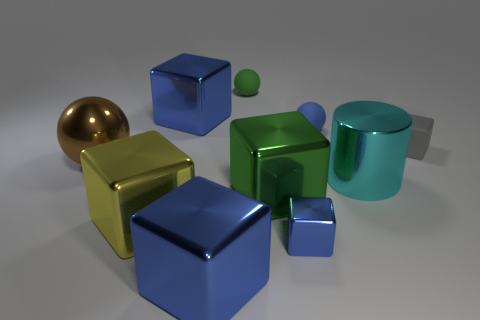How many blocks are either gray matte things or blue rubber objects?
Offer a terse response. 1. There is a shiny cylinder; is its size the same as the green thing that is behind the tiny gray block?
Offer a terse response. No. Are there more brown metal objects behind the large green block than large blue matte cubes?
Your response must be concise. Yes. What size is the blue object that is the same material as the tiny gray block?
Your response must be concise. Small. Are there any metallic cubes that have the same color as the small metal thing?
Your response must be concise. Yes. What number of objects are tiny matte spheres or cubes right of the large yellow metal thing?
Give a very brief answer. 7. Is the number of shiny things greater than the number of small gray rubber objects?
Your answer should be compact. Yes. Is there a cyan cylinder that has the same material as the gray object?
Give a very brief answer. No. There is a blue thing that is both behind the yellow metal object and on the left side of the tiny green matte object; what shape is it?
Your answer should be very brief. Cube. What number of other objects are the same shape as the small blue rubber thing?
Your answer should be very brief. 2. 